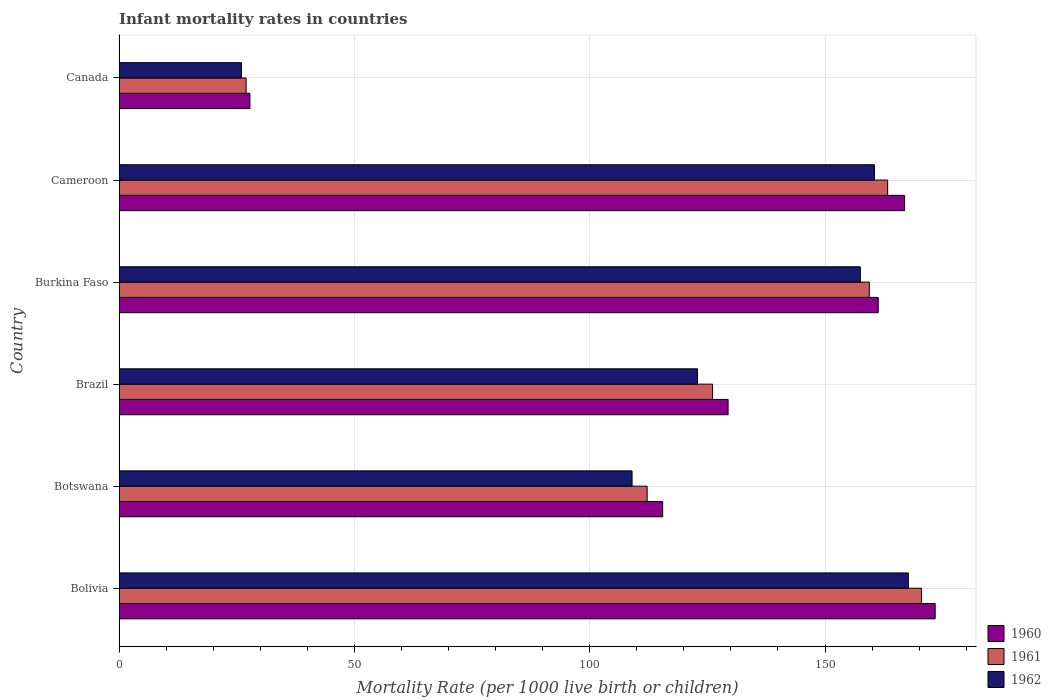How many different coloured bars are there?
Your response must be concise. 3. Are the number of bars per tick equal to the number of legend labels?
Provide a succinct answer. Yes. How many bars are there on the 1st tick from the top?
Offer a terse response. 3. What is the label of the 5th group of bars from the top?
Keep it short and to the point. Botswana. What is the infant mortality rate in 1962 in Burkina Faso?
Provide a short and direct response. 157.5. Across all countries, what is the maximum infant mortality rate in 1961?
Give a very brief answer. 170.5. Across all countries, what is the minimum infant mortality rate in 1961?
Keep it short and to the point. 27. In which country was the infant mortality rate in 1961 maximum?
Keep it short and to the point. Bolivia. In which country was the infant mortality rate in 1960 minimum?
Give a very brief answer. Canada. What is the total infant mortality rate in 1962 in the graph?
Make the answer very short. 743.6. What is the difference between the infant mortality rate in 1962 in Bolivia and that in Burkina Faso?
Ensure brevity in your answer.  10.2. What is the difference between the infant mortality rate in 1962 in Burkina Faso and the infant mortality rate in 1960 in Bolivia?
Ensure brevity in your answer.  -15.9. What is the average infant mortality rate in 1961 per country?
Make the answer very short. 126.42. What is the difference between the infant mortality rate in 1960 and infant mortality rate in 1961 in Burkina Faso?
Keep it short and to the point. 1.9. In how many countries, is the infant mortality rate in 1961 greater than 120 ?
Your answer should be compact. 4. What is the ratio of the infant mortality rate in 1960 in Brazil to that in Burkina Faso?
Give a very brief answer. 0.8. Is the difference between the infant mortality rate in 1960 in Bolivia and Burkina Faso greater than the difference between the infant mortality rate in 1961 in Bolivia and Burkina Faso?
Offer a terse response. Yes. What is the difference between the highest and the second highest infant mortality rate in 1961?
Your answer should be compact. 7.2. What is the difference between the highest and the lowest infant mortality rate in 1961?
Your response must be concise. 143.5. What does the 1st bar from the top in Burkina Faso represents?
Offer a very short reply. 1962. What does the 1st bar from the bottom in Canada represents?
Provide a short and direct response. 1960. How many bars are there?
Provide a short and direct response. 18. Are all the bars in the graph horizontal?
Ensure brevity in your answer.  Yes. What is the difference between two consecutive major ticks on the X-axis?
Provide a succinct answer. 50. Are the values on the major ticks of X-axis written in scientific E-notation?
Ensure brevity in your answer.  No. Does the graph contain any zero values?
Offer a very short reply. No. Does the graph contain grids?
Your answer should be very brief. Yes. Where does the legend appear in the graph?
Your answer should be very brief. Bottom right. How many legend labels are there?
Provide a short and direct response. 3. How are the legend labels stacked?
Provide a short and direct response. Vertical. What is the title of the graph?
Provide a short and direct response. Infant mortality rates in countries. What is the label or title of the X-axis?
Provide a short and direct response. Mortality Rate (per 1000 live birth or children). What is the label or title of the Y-axis?
Make the answer very short. Country. What is the Mortality Rate (per 1000 live birth or children) in 1960 in Bolivia?
Make the answer very short. 173.4. What is the Mortality Rate (per 1000 live birth or children) in 1961 in Bolivia?
Offer a terse response. 170.5. What is the Mortality Rate (per 1000 live birth or children) of 1962 in Bolivia?
Keep it short and to the point. 167.7. What is the Mortality Rate (per 1000 live birth or children) in 1960 in Botswana?
Your response must be concise. 115.5. What is the Mortality Rate (per 1000 live birth or children) in 1961 in Botswana?
Provide a short and direct response. 112.2. What is the Mortality Rate (per 1000 live birth or children) in 1962 in Botswana?
Make the answer very short. 109. What is the Mortality Rate (per 1000 live birth or children) in 1960 in Brazil?
Give a very brief answer. 129.4. What is the Mortality Rate (per 1000 live birth or children) in 1961 in Brazil?
Keep it short and to the point. 126.1. What is the Mortality Rate (per 1000 live birth or children) in 1962 in Brazil?
Give a very brief answer. 122.9. What is the Mortality Rate (per 1000 live birth or children) in 1960 in Burkina Faso?
Give a very brief answer. 161.3. What is the Mortality Rate (per 1000 live birth or children) in 1961 in Burkina Faso?
Offer a very short reply. 159.4. What is the Mortality Rate (per 1000 live birth or children) of 1962 in Burkina Faso?
Your answer should be compact. 157.5. What is the Mortality Rate (per 1000 live birth or children) in 1960 in Cameroon?
Keep it short and to the point. 166.9. What is the Mortality Rate (per 1000 live birth or children) of 1961 in Cameroon?
Provide a succinct answer. 163.3. What is the Mortality Rate (per 1000 live birth or children) in 1962 in Cameroon?
Provide a succinct answer. 160.5. What is the Mortality Rate (per 1000 live birth or children) of 1960 in Canada?
Provide a succinct answer. 27.8. What is the Mortality Rate (per 1000 live birth or children) of 1962 in Canada?
Your answer should be compact. 26. Across all countries, what is the maximum Mortality Rate (per 1000 live birth or children) of 1960?
Your response must be concise. 173.4. Across all countries, what is the maximum Mortality Rate (per 1000 live birth or children) in 1961?
Provide a short and direct response. 170.5. Across all countries, what is the maximum Mortality Rate (per 1000 live birth or children) in 1962?
Offer a terse response. 167.7. Across all countries, what is the minimum Mortality Rate (per 1000 live birth or children) in 1960?
Keep it short and to the point. 27.8. Across all countries, what is the minimum Mortality Rate (per 1000 live birth or children) in 1962?
Your answer should be very brief. 26. What is the total Mortality Rate (per 1000 live birth or children) in 1960 in the graph?
Give a very brief answer. 774.3. What is the total Mortality Rate (per 1000 live birth or children) of 1961 in the graph?
Offer a very short reply. 758.5. What is the total Mortality Rate (per 1000 live birth or children) in 1962 in the graph?
Make the answer very short. 743.6. What is the difference between the Mortality Rate (per 1000 live birth or children) in 1960 in Bolivia and that in Botswana?
Ensure brevity in your answer.  57.9. What is the difference between the Mortality Rate (per 1000 live birth or children) in 1961 in Bolivia and that in Botswana?
Give a very brief answer. 58.3. What is the difference between the Mortality Rate (per 1000 live birth or children) of 1962 in Bolivia and that in Botswana?
Offer a terse response. 58.7. What is the difference between the Mortality Rate (per 1000 live birth or children) of 1961 in Bolivia and that in Brazil?
Give a very brief answer. 44.4. What is the difference between the Mortality Rate (per 1000 live birth or children) in 1962 in Bolivia and that in Brazil?
Ensure brevity in your answer.  44.8. What is the difference between the Mortality Rate (per 1000 live birth or children) in 1961 in Bolivia and that in Burkina Faso?
Give a very brief answer. 11.1. What is the difference between the Mortality Rate (per 1000 live birth or children) of 1962 in Bolivia and that in Burkina Faso?
Your response must be concise. 10.2. What is the difference between the Mortality Rate (per 1000 live birth or children) of 1961 in Bolivia and that in Cameroon?
Your answer should be compact. 7.2. What is the difference between the Mortality Rate (per 1000 live birth or children) in 1962 in Bolivia and that in Cameroon?
Offer a very short reply. 7.2. What is the difference between the Mortality Rate (per 1000 live birth or children) of 1960 in Bolivia and that in Canada?
Offer a very short reply. 145.6. What is the difference between the Mortality Rate (per 1000 live birth or children) in 1961 in Bolivia and that in Canada?
Your answer should be very brief. 143.5. What is the difference between the Mortality Rate (per 1000 live birth or children) of 1962 in Bolivia and that in Canada?
Ensure brevity in your answer.  141.7. What is the difference between the Mortality Rate (per 1000 live birth or children) of 1961 in Botswana and that in Brazil?
Keep it short and to the point. -13.9. What is the difference between the Mortality Rate (per 1000 live birth or children) of 1962 in Botswana and that in Brazil?
Your answer should be very brief. -13.9. What is the difference between the Mortality Rate (per 1000 live birth or children) of 1960 in Botswana and that in Burkina Faso?
Your answer should be very brief. -45.8. What is the difference between the Mortality Rate (per 1000 live birth or children) in 1961 in Botswana and that in Burkina Faso?
Your answer should be compact. -47.2. What is the difference between the Mortality Rate (per 1000 live birth or children) of 1962 in Botswana and that in Burkina Faso?
Keep it short and to the point. -48.5. What is the difference between the Mortality Rate (per 1000 live birth or children) in 1960 in Botswana and that in Cameroon?
Give a very brief answer. -51.4. What is the difference between the Mortality Rate (per 1000 live birth or children) in 1961 in Botswana and that in Cameroon?
Your response must be concise. -51.1. What is the difference between the Mortality Rate (per 1000 live birth or children) of 1962 in Botswana and that in Cameroon?
Offer a very short reply. -51.5. What is the difference between the Mortality Rate (per 1000 live birth or children) of 1960 in Botswana and that in Canada?
Provide a short and direct response. 87.7. What is the difference between the Mortality Rate (per 1000 live birth or children) in 1961 in Botswana and that in Canada?
Keep it short and to the point. 85.2. What is the difference between the Mortality Rate (per 1000 live birth or children) of 1962 in Botswana and that in Canada?
Ensure brevity in your answer.  83. What is the difference between the Mortality Rate (per 1000 live birth or children) of 1960 in Brazil and that in Burkina Faso?
Offer a very short reply. -31.9. What is the difference between the Mortality Rate (per 1000 live birth or children) of 1961 in Brazil and that in Burkina Faso?
Your answer should be compact. -33.3. What is the difference between the Mortality Rate (per 1000 live birth or children) of 1962 in Brazil and that in Burkina Faso?
Your answer should be compact. -34.6. What is the difference between the Mortality Rate (per 1000 live birth or children) of 1960 in Brazil and that in Cameroon?
Your response must be concise. -37.5. What is the difference between the Mortality Rate (per 1000 live birth or children) of 1961 in Brazil and that in Cameroon?
Offer a very short reply. -37.2. What is the difference between the Mortality Rate (per 1000 live birth or children) in 1962 in Brazil and that in Cameroon?
Give a very brief answer. -37.6. What is the difference between the Mortality Rate (per 1000 live birth or children) in 1960 in Brazil and that in Canada?
Your answer should be very brief. 101.6. What is the difference between the Mortality Rate (per 1000 live birth or children) of 1961 in Brazil and that in Canada?
Offer a terse response. 99.1. What is the difference between the Mortality Rate (per 1000 live birth or children) of 1962 in Brazil and that in Canada?
Keep it short and to the point. 96.9. What is the difference between the Mortality Rate (per 1000 live birth or children) of 1961 in Burkina Faso and that in Cameroon?
Your answer should be very brief. -3.9. What is the difference between the Mortality Rate (per 1000 live birth or children) of 1962 in Burkina Faso and that in Cameroon?
Provide a succinct answer. -3. What is the difference between the Mortality Rate (per 1000 live birth or children) of 1960 in Burkina Faso and that in Canada?
Offer a terse response. 133.5. What is the difference between the Mortality Rate (per 1000 live birth or children) in 1961 in Burkina Faso and that in Canada?
Your response must be concise. 132.4. What is the difference between the Mortality Rate (per 1000 live birth or children) of 1962 in Burkina Faso and that in Canada?
Make the answer very short. 131.5. What is the difference between the Mortality Rate (per 1000 live birth or children) in 1960 in Cameroon and that in Canada?
Your response must be concise. 139.1. What is the difference between the Mortality Rate (per 1000 live birth or children) of 1961 in Cameroon and that in Canada?
Provide a short and direct response. 136.3. What is the difference between the Mortality Rate (per 1000 live birth or children) of 1962 in Cameroon and that in Canada?
Your answer should be compact. 134.5. What is the difference between the Mortality Rate (per 1000 live birth or children) in 1960 in Bolivia and the Mortality Rate (per 1000 live birth or children) in 1961 in Botswana?
Your response must be concise. 61.2. What is the difference between the Mortality Rate (per 1000 live birth or children) of 1960 in Bolivia and the Mortality Rate (per 1000 live birth or children) of 1962 in Botswana?
Offer a terse response. 64.4. What is the difference between the Mortality Rate (per 1000 live birth or children) in 1961 in Bolivia and the Mortality Rate (per 1000 live birth or children) in 1962 in Botswana?
Provide a short and direct response. 61.5. What is the difference between the Mortality Rate (per 1000 live birth or children) of 1960 in Bolivia and the Mortality Rate (per 1000 live birth or children) of 1961 in Brazil?
Keep it short and to the point. 47.3. What is the difference between the Mortality Rate (per 1000 live birth or children) of 1960 in Bolivia and the Mortality Rate (per 1000 live birth or children) of 1962 in Brazil?
Offer a terse response. 50.5. What is the difference between the Mortality Rate (per 1000 live birth or children) of 1961 in Bolivia and the Mortality Rate (per 1000 live birth or children) of 1962 in Brazil?
Your answer should be very brief. 47.6. What is the difference between the Mortality Rate (per 1000 live birth or children) of 1960 in Bolivia and the Mortality Rate (per 1000 live birth or children) of 1962 in Burkina Faso?
Your answer should be very brief. 15.9. What is the difference between the Mortality Rate (per 1000 live birth or children) in 1960 in Bolivia and the Mortality Rate (per 1000 live birth or children) in 1961 in Canada?
Your answer should be compact. 146.4. What is the difference between the Mortality Rate (per 1000 live birth or children) of 1960 in Bolivia and the Mortality Rate (per 1000 live birth or children) of 1962 in Canada?
Provide a succinct answer. 147.4. What is the difference between the Mortality Rate (per 1000 live birth or children) in 1961 in Bolivia and the Mortality Rate (per 1000 live birth or children) in 1962 in Canada?
Keep it short and to the point. 144.5. What is the difference between the Mortality Rate (per 1000 live birth or children) in 1961 in Botswana and the Mortality Rate (per 1000 live birth or children) in 1962 in Brazil?
Provide a succinct answer. -10.7. What is the difference between the Mortality Rate (per 1000 live birth or children) of 1960 in Botswana and the Mortality Rate (per 1000 live birth or children) of 1961 in Burkina Faso?
Give a very brief answer. -43.9. What is the difference between the Mortality Rate (per 1000 live birth or children) in 1960 in Botswana and the Mortality Rate (per 1000 live birth or children) in 1962 in Burkina Faso?
Make the answer very short. -42. What is the difference between the Mortality Rate (per 1000 live birth or children) in 1961 in Botswana and the Mortality Rate (per 1000 live birth or children) in 1962 in Burkina Faso?
Your answer should be compact. -45.3. What is the difference between the Mortality Rate (per 1000 live birth or children) in 1960 in Botswana and the Mortality Rate (per 1000 live birth or children) in 1961 in Cameroon?
Provide a succinct answer. -47.8. What is the difference between the Mortality Rate (per 1000 live birth or children) in 1960 in Botswana and the Mortality Rate (per 1000 live birth or children) in 1962 in Cameroon?
Your answer should be very brief. -45. What is the difference between the Mortality Rate (per 1000 live birth or children) of 1961 in Botswana and the Mortality Rate (per 1000 live birth or children) of 1962 in Cameroon?
Your response must be concise. -48.3. What is the difference between the Mortality Rate (per 1000 live birth or children) in 1960 in Botswana and the Mortality Rate (per 1000 live birth or children) in 1961 in Canada?
Make the answer very short. 88.5. What is the difference between the Mortality Rate (per 1000 live birth or children) in 1960 in Botswana and the Mortality Rate (per 1000 live birth or children) in 1962 in Canada?
Make the answer very short. 89.5. What is the difference between the Mortality Rate (per 1000 live birth or children) in 1961 in Botswana and the Mortality Rate (per 1000 live birth or children) in 1962 in Canada?
Your answer should be very brief. 86.2. What is the difference between the Mortality Rate (per 1000 live birth or children) in 1960 in Brazil and the Mortality Rate (per 1000 live birth or children) in 1961 in Burkina Faso?
Keep it short and to the point. -30. What is the difference between the Mortality Rate (per 1000 live birth or children) of 1960 in Brazil and the Mortality Rate (per 1000 live birth or children) of 1962 in Burkina Faso?
Your answer should be compact. -28.1. What is the difference between the Mortality Rate (per 1000 live birth or children) in 1961 in Brazil and the Mortality Rate (per 1000 live birth or children) in 1962 in Burkina Faso?
Give a very brief answer. -31.4. What is the difference between the Mortality Rate (per 1000 live birth or children) in 1960 in Brazil and the Mortality Rate (per 1000 live birth or children) in 1961 in Cameroon?
Your response must be concise. -33.9. What is the difference between the Mortality Rate (per 1000 live birth or children) of 1960 in Brazil and the Mortality Rate (per 1000 live birth or children) of 1962 in Cameroon?
Offer a very short reply. -31.1. What is the difference between the Mortality Rate (per 1000 live birth or children) of 1961 in Brazil and the Mortality Rate (per 1000 live birth or children) of 1962 in Cameroon?
Provide a short and direct response. -34.4. What is the difference between the Mortality Rate (per 1000 live birth or children) of 1960 in Brazil and the Mortality Rate (per 1000 live birth or children) of 1961 in Canada?
Keep it short and to the point. 102.4. What is the difference between the Mortality Rate (per 1000 live birth or children) in 1960 in Brazil and the Mortality Rate (per 1000 live birth or children) in 1962 in Canada?
Offer a terse response. 103.4. What is the difference between the Mortality Rate (per 1000 live birth or children) of 1961 in Brazil and the Mortality Rate (per 1000 live birth or children) of 1962 in Canada?
Your answer should be very brief. 100.1. What is the difference between the Mortality Rate (per 1000 live birth or children) in 1960 in Burkina Faso and the Mortality Rate (per 1000 live birth or children) in 1961 in Canada?
Keep it short and to the point. 134.3. What is the difference between the Mortality Rate (per 1000 live birth or children) in 1960 in Burkina Faso and the Mortality Rate (per 1000 live birth or children) in 1962 in Canada?
Your answer should be very brief. 135.3. What is the difference between the Mortality Rate (per 1000 live birth or children) of 1961 in Burkina Faso and the Mortality Rate (per 1000 live birth or children) of 1962 in Canada?
Your response must be concise. 133.4. What is the difference between the Mortality Rate (per 1000 live birth or children) in 1960 in Cameroon and the Mortality Rate (per 1000 live birth or children) in 1961 in Canada?
Make the answer very short. 139.9. What is the difference between the Mortality Rate (per 1000 live birth or children) of 1960 in Cameroon and the Mortality Rate (per 1000 live birth or children) of 1962 in Canada?
Your answer should be compact. 140.9. What is the difference between the Mortality Rate (per 1000 live birth or children) in 1961 in Cameroon and the Mortality Rate (per 1000 live birth or children) in 1962 in Canada?
Ensure brevity in your answer.  137.3. What is the average Mortality Rate (per 1000 live birth or children) in 1960 per country?
Ensure brevity in your answer.  129.05. What is the average Mortality Rate (per 1000 live birth or children) of 1961 per country?
Provide a succinct answer. 126.42. What is the average Mortality Rate (per 1000 live birth or children) in 1962 per country?
Make the answer very short. 123.93. What is the difference between the Mortality Rate (per 1000 live birth or children) in 1960 and Mortality Rate (per 1000 live birth or children) in 1961 in Bolivia?
Give a very brief answer. 2.9. What is the difference between the Mortality Rate (per 1000 live birth or children) of 1960 and Mortality Rate (per 1000 live birth or children) of 1962 in Bolivia?
Offer a very short reply. 5.7. What is the difference between the Mortality Rate (per 1000 live birth or children) in 1960 and Mortality Rate (per 1000 live birth or children) in 1961 in Botswana?
Offer a terse response. 3.3. What is the difference between the Mortality Rate (per 1000 live birth or children) of 1960 and Mortality Rate (per 1000 live birth or children) of 1962 in Botswana?
Ensure brevity in your answer.  6.5. What is the difference between the Mortality Rate (per 1000 live birth or children) in 1960 and Mortality Rate (per 1000 live birth or children) in 1962 in Brazil?
Make the answer very short. 6.5. What is the difference between the Mortality Rate (per 1000 live birth or children) in 1961 and Mortality Rate (per 1000 live birth or children) in 1962 in Brazil?
Offer a terse response. 3.2. What is the difference between the Mortality Rate (per 1000 live birth or children) in 1961 and Mortality Rate (per 1000 live birth or children) in 1962 in Burkina Faso?
Give a very brief answer. 1.9. What is the difference between the Mortality Rate (per 1000 live birth or children) of 1960 and Mortality Rate (per 1000 live birth or children) of 1961 in Cameroon?
Provide a short and direct response. 3.6. What is the difference between the Mortality Rate (per 1000 live birth or children) of 1960 and Mortality Rate (per 1000 live birth or children) of 1962 in Cameroon?
Provide a short and direct response. 6.4. What is the ratio of the Mortality Rate (per 1000 live birth or children) of 1960 in Bolivia to that in Botswana?
Offer a terse response. 1.5. What is the ratio of the Mortality Rate (per 1000 live birth or children) in 1961 in Bolivia to that in Botswana?
Your answer should be compact. 1.52. What is the ratio of the Mortality Rate (per 1000 live birth or children) of 1962 in Bolivia to that in Botswana?
Provide a succinct answer. 1.54. What is the ratio of the Mortality Rate (per 1000 live birth or children) of 1960 in Bolivia to that in Brazil?
Offer a terse response. 1.34. What is the ratio of the Mortality Rate (per 1000 live birth or children) of 1961 in Bolivia to that in Brazil?
Your answer should be compact. 1.35. What is the ratio of the Mortality Rate (per 1000 live birth or children) of 1962 in Bolivia to that in Brazil?
Your answer should be very brief. 1.36. What is the ratio of the Mortality Rate (per 1000 live birth or children) of 1960 in Bolivia to that in Burkina Faso?
Provide a short and direct response. 1.07. What is the ratio of the Mortality Rate (per 1000 live birth or children) in 1961 in Bolivia to that in Burkina Faso?
Give a very brief answer. 1.07. What is the ratio of the Mortality Rate (per 1000 live birth or children) of 1962 in Bolivia to that in Burkina Faso?
Provide a short and direct response. 1.06. What is the ratio of the Mortality Rate (per 1000 live birth or children) of 1960 in Bolivia to that in Cameroon?
Give a very brief answer. 1.04. What is the ratio of the Mortality Rate (per 1000 live birth or children) of 1961 in Bolivia to that in Cameroon?
Ensure brevity in your answer.  1.04. What is the ratio of the Mortality Rate (per 1000 live birth or children) in 1962 in Bolivia to that in Cameroon?
Your answer should be compact. 1.04. What is the ratio of the Mortality Rate (per 1000 live birth or children) of 1960 in Bolivia to that in Canada?
Provide a short and direct response. 6.24. What is the ratio of the Mortality Rate (per 1000 live birth or children) in 1961 in Bolivia to that in Canada?
Make the answer very short. 6.31. What is the ratio of the Mortality Rate (per 1000 live birth or children) in 1962 in Bolivia to that in Canada?
Keep it short and to the point. 6.45. What is the ratio of the Mortality Rate (per 1000 live birth or children) of 1960 in Botswana to that in Brazil?
Your answer should be compact. 0.89. What is the ratio of the Mortality Rate (per 1000 live birth or children) in 1961 in Botswana to that in Brazil?
Provide a short and direct response. 0.89. What is the ratio of the Mortality Rate (per 1000 live birth or children) of 1962 in Botswana to that in Brazil?
Make the answer very short. 0.89. What is the ratio of the Mortality Rate (per 1000 live birth or children) in 1960 in Botswana to that in Burkina Faso?
Your answer should be compact. 0.72. What is the ratio of the Mortality Rate (per 1000 live birth or children) of 1961 in Botswana to that in Burkina Faso?
Provide a short and direct response. 0.7. What is the ratio of the Mortality Rate (per 1000 live birth or children) in 1962 in Botswana to that in Burkina Faso?
Give a very brief answer. 0.69. What is the ratio of the Mortality Rate (per 1000 live birth or children) of 1960 in Botswana to that in Cameroon?
Keep it short and to the point. 0.69. What is the ratio of the Mortality Rate (per 1000 live birth or children) of 1961 in Botswana to that in Cameroon?
Your response must be concise. 0.69. What is the ratio of the Mortality Rate (per 1000 live birth or children) in 1962 in Botswana to that in Cameroon?
Offer a terse response. 0.68. What is the ratio of the Mortality Rate (per 1000 live birth or children) in 1960 in Botswana to that in Canada?
Offer a very short reply. 4.15. What is the ratio of the Mortality Rate (per 1000 live birth or children) in 1961 in Botswana to that in Canada?
Keep it short and to the point. 4.16. What is the ratio of the Mortality Rate (per 1000 live birth or children) of 1962 in Botswana to that in Canada?
Offer a terse response. 4.19. What is the ratio of the Mortality Rate (per 1000 live birth or children) in 1960 in Brazil to that in Burkina Faso?
Provide a succinct answer. 0.8. What is the ratio of the Mortality Rate (per 1000 live birth or children) of 1961 in Brazil to that in Burkina Faso?
Make the answer very short. 0.79. What is the ratio of the Mortality Rate (per 1000 live birth or children) in 1962 in Brazil to that in Burkina Faso?
Your answer should be compact. 0.78. What is the ratio of the Mortality Rate (per 1000 live birth or children) of 1960 in Brazil to that in Cameroon?
Your answer should be compact. 0.78. What is the ratio of the Mortality Rate (per 1000 live birth or children) in 1961 in Brazil to that in Cameroon?
Your answer should be compact. 0.77. What is the ratio of the Mortality Rate (per 1000 live birth or children) in 1962 in Brazil to that in Cameroon?
Offer a terse response. 0.77. What is the ratio of the Mortality Rate (per 1000 live birth or children) in 1960 in Brazil to that in Canada?
Your answer should be compact. 4.65. What is the ratio of the Mortality Rate (per 1000 live birth or children) in 1961 in Brazil to that in Canada?
Keep it short and to the point. 4.67. What is the ratio of the Mortality Rate (per 1000 live birth or children) of 1962 in Brazil to that in Canada?
Provide a short and direct response. 4.73. What is the ratio of the Mortality Rate (per 1000 live birth or children) in 1960 in Burkina Faso to that in Cameroon?
Make the answer very short. 0.97. What is the ratio of the Mortality Rate (per 1000 live birth or children) in 1961 in Burkina Faso to that in Cameroon?
Make the answer very short. 0.98. What is the ratio of the Mortality Rate (per 1000 live birth or children) in 1962 in Burkina Faso to that in Cameroon?
Ensure brevity in your answer.  0.98. What is the ratio of the Mortality Rate (per 1000 live birth or children) in 1960 in Burkina Faso to that in Canada?
Your answer should be very brief. 5.8. What is the ratio of the Mortality Rate (per 1000 live birth or children) of 1961 in Burkina Faso to that in Canada?
Your answer should be compact. 5.9. What is the ratio of the Mortality Rate (per 1000 live birth or children) of 1962 in Burkina Faso to that in Canada?
Make the answer very short. 6.06. What is the ratio of the Mortality Rate (per 1000 live birth or children) in 1960 in Cameroon to that in Canada?
Make the answer very short. 6. What is the ratio of the Mortality Rate (per 1000 live birth or children) of 1961 in Cameroon to that in Canada?
Your answer should be very brief. 6.05. What is the ratio of the Mortality Rate (per 1000 live birth or children) of 1962 in Cameroon to that in Canada?
Offer a very short reply. 6.17. What is the difference between the highest and the second highest Mortality Rate (per 1000 live birth or children) in 1960?
Your response must be concise. 6.5. What is the difference between the highest and the lowest Mortality Rate (per 1000 live birth or children) of 1960?
Ensure brevity in your answer.  145.6. What is the difference between the highest and the lowest Mortality Rate (per 1000 live birth or children) of 1961?
Provide a short and direct response. 143.5. What is the difference between the highest and the lowest Mortality Rate (per 1000 live birth or children) in 1962?
Your answer should be very brief. 141.7. 